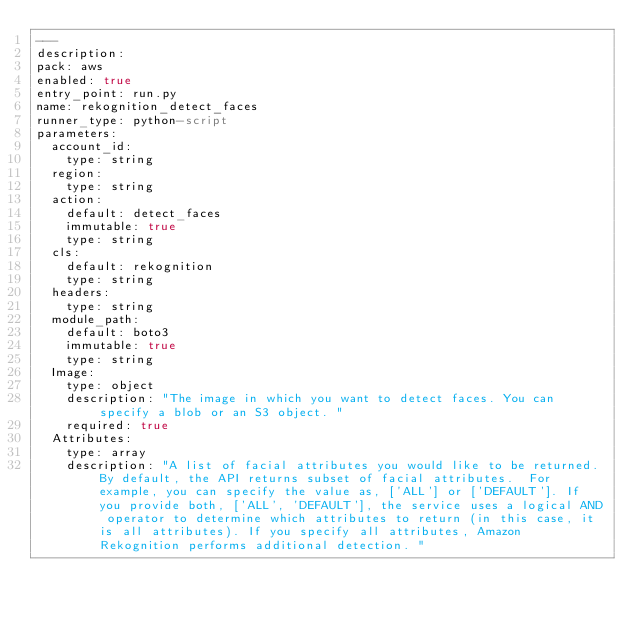<code> <loc_0><loc_0><loc_500><loc_500><_YAML_>---
description: 
pack: aws
enabled: true
entry_point: run.py
name: rekognition_detect_faces
runner_type: python-script
parameters:
  account_id:
    type: string
  region:
    type: string
  action:
    default: detect_faces
    immutable: true
    type: string
  cls:
    default: rekognition
    type: string
  headers:
    type: string
  module_path:
    default: boto3
    immutable: true
    type: string
  Image:
    type: object
    description: "The image in which you want to detect faces. You can specify a blob or an S3 object. "
    required: true
  Attributes:
    type: array
    description: "A list of facial attributes you would like to be returned. By default, the API returns subset of facial attributes.  For example, you can specify the value as, ['ALL'] or ['DEFAULT']. If you provide both, ['ALL', 'DEFAULT'], the service uses a logical AND operator to determine which attributes to return (in this case, it is all attributes). If you specify all attributes, Amazon Rekognition performs additional detection. "</code> 